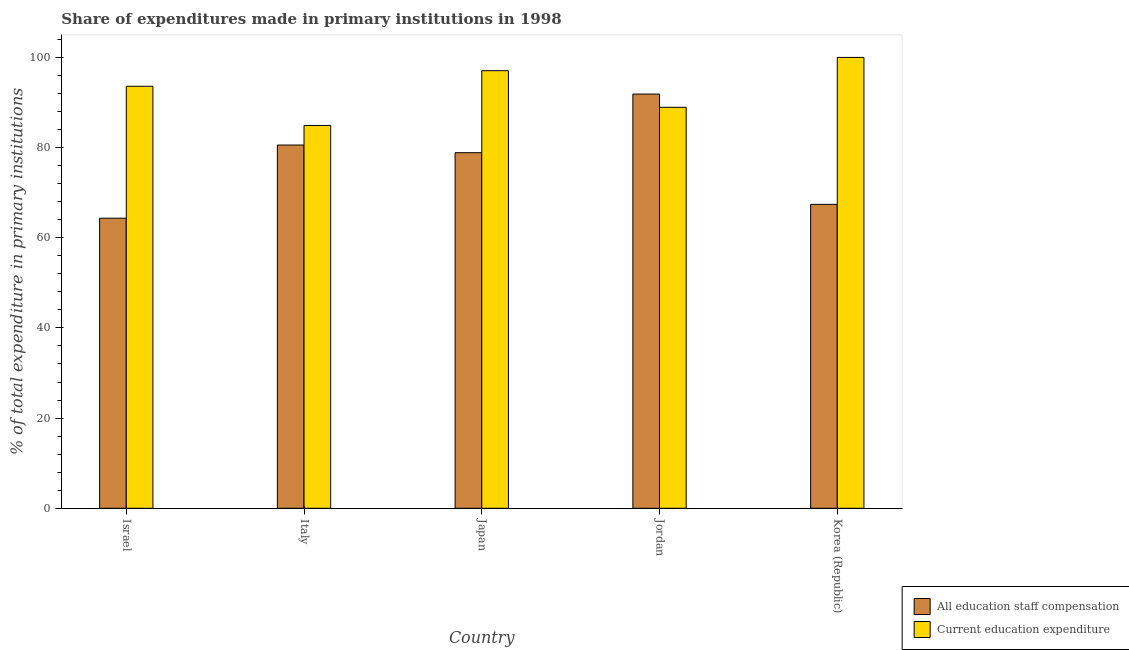How many different coloured bars are there?
Make the answer very short. 2. How many bars are there on the 5th tick from the left?
Make the answer very short. 2. How many bars are there on the 4th tick from the right?
Offer a terse response. 2. What is the label of the 4th group of bars from the left?
Offer a terse response. Jordan. What is the expenditure in staff compensation in Korea (Republic)?
Make the answer very short. 67.41. Across all countries, what is the maximum expenditure in education?
Your answer should be very brief. 100. Across all countries, what is the minimum expenditure in education?
Your answer should be compact. 84.91. In which country was the expenditure in education maximum?
Ensure brevity in your answer.  Korea (Republic). What is the total expenditure in staff compensation in the graph?
Give a very brief answer. 383.05. What is the difference between the expenditure in education in Italy and that in Japan?
Provide a succinct answer. -12.14. What is the difference between the expenditure in staff compensation in Japan and the expenditure in education in Korea (Republic)?
Your answer should be compact. -21.13. What is the average expenditure in staff compensation per country?
Provide a short and direct response. 76.61. What is the difference between the expenditure in staff compensation and expenditure in education in Jordan?
Keep it short and to the point. 2.94. In how many countries, is the expenditure in staff compensation greater than 44 %?
Your answer should be compact. 5. What is the ratio of the expenditure in education in Israel to that in Japan?
Offer a very short reply. 0.96. Is the difference between the expenditure in education in Jordan and Korea (Republic) greater than the difference between the expenditure in staff compensation in Jordan and Korea (Republic)?
Your answer should be very brief. No. What is the difference between the highest and the second highest expenditure in education?
Provide a succinct answer. 2.95. What is the difference between the highest and the lowest expenditure in education?
Keep it short and to the point. 15.09. What does the 1st bar from the left in Jordan represents?
Offer a terse response. All education staff compensation. What does the 2nd bar from the right in Korea (Republic) represents?
Provide a succinct answer. All education staff compensation. How many countries are there in the graph?
Your answer should be very brief. 5. Does the graph contain any zero values?
Provide a short and direct response. No. Where does the legend appear in the graph?
Provide a succinct answer. Bottom right. How many legend labels are there?
Offer a terse response. 2. What is the title of the graph?
Make the answer very short. Share of expenditures made in primary institutions in 1998. What is the label or title of the Y-axis?
Provide a short and direct response. % of total expenditure in primary institutions. What is the % of total expenditure in primary institutions in All education staff compensation in Israel?
Make the answer very short. 64.34. What is the % of total expenditure in primary institutions in Current education expenditure in Israel?
Make the answer very short. 93.6. What is the % of total expenditure in primary institutions of All education staff compensation in Italy?
Offer a terse response. 80.57. What is the % of total expenditure in primary institutions of Current education expenditure in Italy?
Your response must be concise. 84.91. What is the % of total expenditure in primary institutions of All education staff compensation in Japan?
Make the answer very short. 78.87. What is the % of total expenditure in primary institutions of Current education expenditure in Japan?
Provide a short and direct response. 97.05. What is the % of total expenditure in primary institutions of All education staff compensation in Jordan?
Provide a succinct answer. 91.87. What is the % of total expenditure in primary institutions of Current education expenditure in Jordan?
Your answer should be compact. 88.93. What is the % of total expenditure in primary institutions of All education staff compensation in Korea (Republic)?
Your answer should be compact. 67.41. Across all countries, what is the maximum % of total expenditure in primary institutions of All education staff compensation?
Your answer should be compact. 91.87. Across all countries, what is the maximum % of total expenditure in primary institutions of Current education expenditure?
Offer a very short reply. 100. Across all countries, what is the minimum % of total expenditure in primary institutions of All education staff compensation?
Keep it short and to the point. 64.34. Across all countries, what is the minimum % of total expenditure in primary institutions of Current education expenditure?
Ensure brevity in your answer.  84.91. What is the total % of total expenditure in primary institutions in All education staff compensation in the graph?
Your response must be concise. 383.05. What is the total % of total expenditure in primary institutions of Current education expenditure in the graph?
Give a very brief answer. 464.5. What is the difference between the % of total expenditure in primary institutions of All education staff compensation in Israel and that in Italy?
Your response must be concise. -16.23. What is the difference between the % of total expenditure in primary institutions of Current education expenditure in Israel and that in Italy?
Provide a succinct answer. 8.69. What is the difference between the % of total expenditure in primary institutions of All education staff compensation in Israel and that in Japan?
Your answer should be compact. -14.53. What is the difference between the % of total expenditure in primary institutions of Current education expenditure in Israel and that in Japan?
Provide a short and direct response. -3.46. What is the difference between the % of total expenditure in primary institutions of All education staff compensation in Israel and that in Jordan?
Your response must be concise. -27.53. What is the difference between the % of total expenditure in primary institutions in Current education expenditure in Israel and that in Jordan?
Your answer should be compact. 4.66. What is the difference between the % of total expenditure in primary institutions in All education staff compensation in Israel and that in Korea (Republic)?
Your answer should be very brief. -3.07. What is the difference between the % of total expenditure in primary institutions in Current education expenditure in Israel and that in Korea (Republic)?
Give a very brief answer. -6.4. What is the difference between the % of total expenditure in primary institutions in All education staff compensation in Italy and that in Japan?
Your answer should be compact. 1.7. What is the difference between the % of total expenditure in primary institutions in Current education expenditure in Italy and that in Japan?
Provide a succinct answer. -12.14. What is the difference between the % of total expenditure in primary institutions of All education staff compensation in Italy and that in Jordan?
Keep it short and to the point. -11.3. What is the difference between the % of total expenditure in primary institutions in Current education expenditure in Italy and that in Jordan?
Your answer should be very brief. -4.02. What is the difference between the % of total expenditure in primary institutions in All education staff compensation in Italy and that in Korea (Republic)?
Provide a succinct answer. 13.16. What is the difference between the % of total expenditure in primary institutions in Current education expenditure in Italy and that in Korea (Republic)?
Your answer should be very brief. -15.09. What is the difference between the % of total expenditure in primary institutions in All education staff compensation in Japan and that in Jordan?
Offer a very short reply. -13. What is the difference between the % of total expenditure in primary institutions of Current education expenditure in Japan and that in Jordan?
Provide a succinct answer. 8.12. What is the difference between the % of total expenditure in primary institutions in All education staff compensation in Japan and that in Korea (Republic)?
Keep it short and to the point. 11.45. What is the difference between the % of total expenditure in primary institutions of Current education expenditure in Japan and that in Korea (Republic)?
Your answer should be very brief. -2.95. What is the difference between the % of total expenditure in primary institutions of All education staff compensation in Jordan and that in Korea (Republic)?
Ensure brevity in your answer.  24.46. What is the difference between the % of total expenditure in primary institutions of Current education expenditure in Jordan and that in Korea (Republic)?
Give a very brief answer. -11.07. What is the difference between the % of total expenditure in primary institutions in All education staff compensation in Israel and the % of total expenditure in primary institutions in Current education expenditure in Italy?
Offer a very short reply. -20.57. What is the difference between the % of total expenditure in primary institutions in All education staff compensation in Israel and the % of total expenditure in primary institutions in Current education expenditure in Japan?
Give a very brief answer. -32.71. What is the difference between the % of total expenditure in primary institutions in All education staff compensation in Israel and the % of total expenditure in primary institutions in Current education expenditure in Jordan?
Offer a very short reply. -24.59. What is the difference between the % of total expenditure in primary institutions of All education staff compensation in Israel and the % of total expenditure in primary institutions of Current education expenditure in Korea (Republic)?
Your answer should be very brief. -35.66. What is the difference between the % of total expenditure in primary institutions in All education staff compensation in Italy and the % of total expenditure in primary institutions in Current education expenditure in Japan?
Make the answer very short. -16.49. What is the difference between the % of total expenditure in primary institutions in All education staff compensation in Italy and the % of total expenditure in primary institutions in Current education expenditure in Jordan?
Your answer should be very brief. -8.37. What is the difference between the % of total expenditure in primary institutions in All education staff compensation in Italy and the % of total expenditure in primary institutions in Current education expenditure in Korea (Republic)?
Make the answer very short. -19.43. What is the difference between the % of total expenditure in primary institutions in All education staff compensation in Japan and the % of total expenditure in primary institutions in Current education expenditure in Jordan?
Make the answer very short. -10.07. What is the difference between the % of total expenditure in primary institutions in All education staff compensation in Japan and the % of total expenditure in primary institutions in Current education expenditure in Korea (Republic)?
Your answer should be very brief. -21.13. What is the difference between the % of total expenditure in primary institutions of All education staff compensation in Jordan and the % of total expenditure in primary institutions of Current education expenditure in Korea (Republic)?
Offer a terse response. -8.13. What is the average % of total expenditure in primary institutions in All education staff compensation per country?
Provide a succinct answer. 76.61. What is the average % of total expenditure in primary institutions of Current education expenditure per country?
Your answer should be very brief. 92.9. What is the difference between the % of total expenditure in primary institutions of All education staff compensation and % of total expenditure in primary institutions of Current education expenditure in Israel?
Offer a terse response. -29.26. What is the difference between the % of total expenditure in primary institutions in All education staff compensation and % of total expenditure in primary institutions in Current education expenditure in Italy?
Offer a terse response. -4.35. What is the difference between the % of total expenditure in primary institutions of All education staff compensation and % of total expenditure in primary institutions of Current education expenditure in Japan?
Your answer should be very brief. -18.19. What is the difference between the % of total expenditure in primary institutions in All education staff compensation and % of total expenditure in primary institutions in Current education expenditure in Jordan?
Provide a short and direct response. 2.94. What is the difference between the % of total expenditure in primary institutions in All education staff compensation and % of total expenditure in primary institutions in Current education expenditure in Korea (Republic)?
Provide a short and direct response. -32.59. What is the ratio of the % of total expenditure in primary institutions in All education staff compensation in Israel to that in Italy?
Your answer should be compact. 0.8. What is the ratio of the % of total expenditure in primary institutions in Current education expenditure in Israel to that in Italy?
Give a very brief answer. 1.1. What is the ratio of the % of total expenditure in primary institutions of All education staff compensation in Israel to that in Japan?
Ensure brevity in your answer.  0.82. What is the ratio of the % of total expenditure in primary institutions of Current education expenditure in Israel to that in Japan?
Your answer should be very brief. 0.96. What is the ratio of the % of total expenditure in primary institutions of All education staff compensation in Israel to that in Jordan?
Make the answer very short. 0.7. What is the ratio of the % of total expenditure in primary institutions of Current education expenditure in Israel to that in Jordan?
Give a very brief answer. 1.05. What is the ratio of the % of total expenditure in primary institutions in All education staff compensation in Israel to that in Korea (Republic)?
Give a very brief answer. 0.95. What is the ratio of the % of total expenditure in primary institutions in Current education expenditure in Israel to that in Korea (Republic)?
Make the answer very short. 0.94. What is the ratio of the % of total expenditure in primary institutions of All education staff compensation in Italy to that in Japan?
Ensure brevity in your answer.  1.02. What is the ratio of the % of total expenditure in primary institutions of Current education expenditure in Italy to that in Japan?
Your response must be concise. 0.87. What is the ratio of the % of total expenditure in primary institutions in All education staff compensation in Italy to that in Jordan?
Give a very brief answer. 0.88. What is the ratio of the % of total expenditure in primary institutions in Current education expenditure in Italy to that in Jordan?
Your response must be concise. 0.95. What is the ratio of the % of total expenditure in primary institutions in All education staff compensation in Italy to that in Korea (Republic)?
Your answer should be compact. 1.2. What is the ratio of the % of total expenditure in primary institutions in Current education expenditure in Italy to that in Korea (Republic)?
Offer a terse response. 0.85. What is the ratio of the % of total expenditure in primary institutions of All education staff compensation in Japan to that in Jordan?
Give a very brief answer. 0.86. What is the ratio of the % of total expenditure in primary institutions in Current education expenditure in Japan to that in Jordan?
Provide a short and direct response. 1.09. What is the ratio of the % of total expenditure in primary institutions of All education staff compensation in Japan to that in Korea (Republic)?
Your response must be concise. 1.17. What is the ratio of the % of total expenditure in primary institutions of Current education expenditure in Japan to that in Korea (Republic)?
Offer a terse response. 0.97. What is the ratio of the % of total expenditure in primary institutions in All education staff compensation in Jordan to that in Korea (Republic)?
Offer a very short reply. 1.36. What is the ratio of the % of total expenditure in primary institutions of Current education expenditure in Jordan to that in Korea (Republic)?
Ensure brevity in your answer.  0.89. What is the difference between the highest and the second highest % of total expenditure in primary institutions in All education staff compensation?
Provide a short and direct response. 11.3. What is the difference between the highest and the second highest % of total expenditure in primary institutions of Current education expenditure?
Make the answer very short. 2.95. What is the difference between the highest and the lowest % of total expenditure in primary institutions of All education staff compensation?
Your answer should be very brief. 27.53. What is the difference between the highest and the lowest % of total expenditure in primary institutions in Current education expenditure?
Provide a succinct answer. 15.09. 